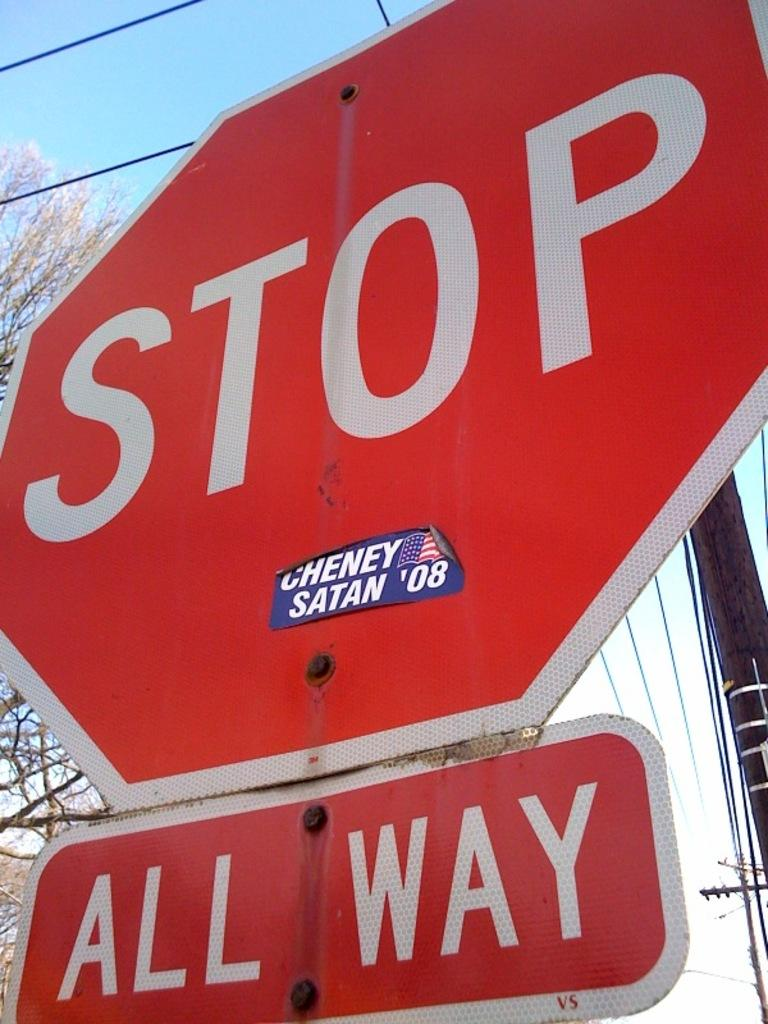<image>
Summarize the visual content of the image. A stop sign has a smaller sign beneath it that says All Way. 